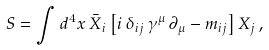Convert formula to latex. <formula><loc_0><loc_0><loc_500><loc_500>S = \int d ^ { 4 } x \, { \bar { X } } _ { i } \left [ i \, \delta _ { i j } \, \gamma ^ { \mu } \, \partial _ { \mu } - m _ { i j } \right ] X _ { j } \, ,</formula> 